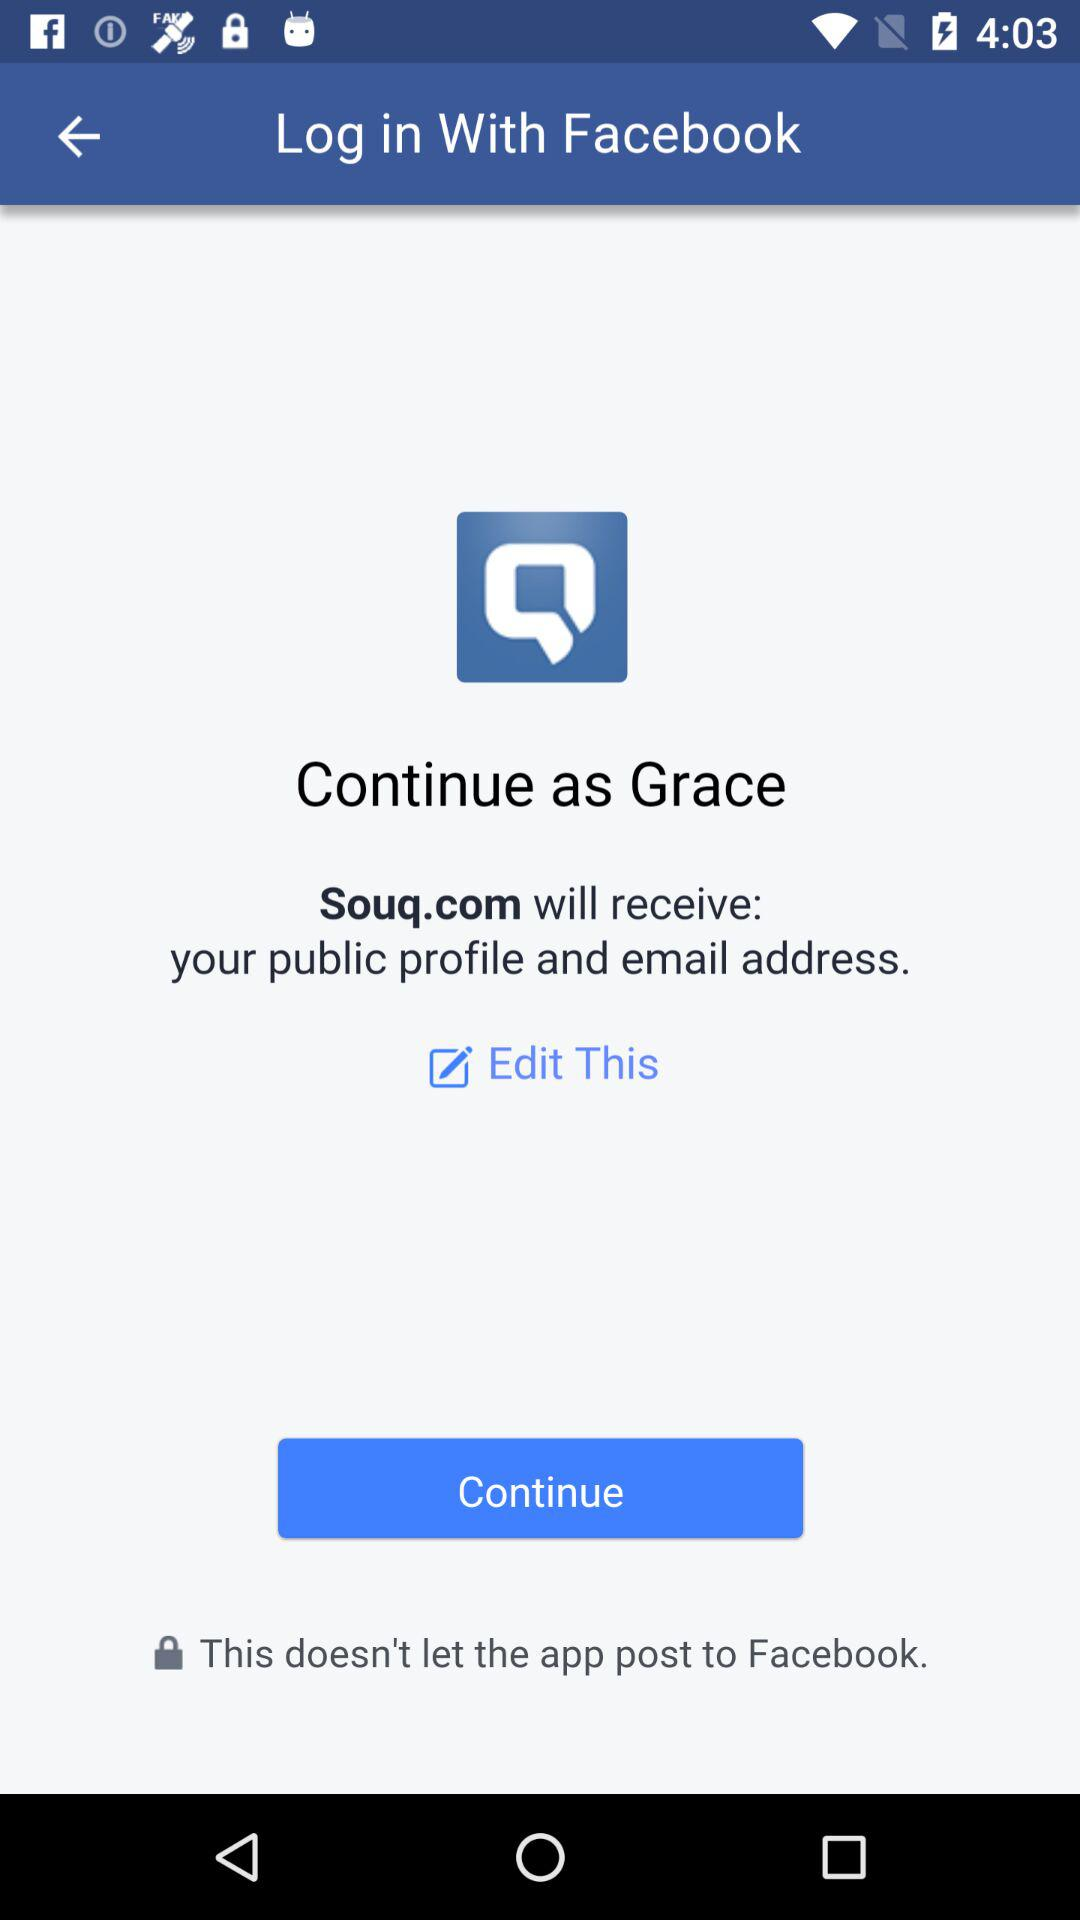What information will Souq.com receive? The Souq.com will receive your public profile and email address. 